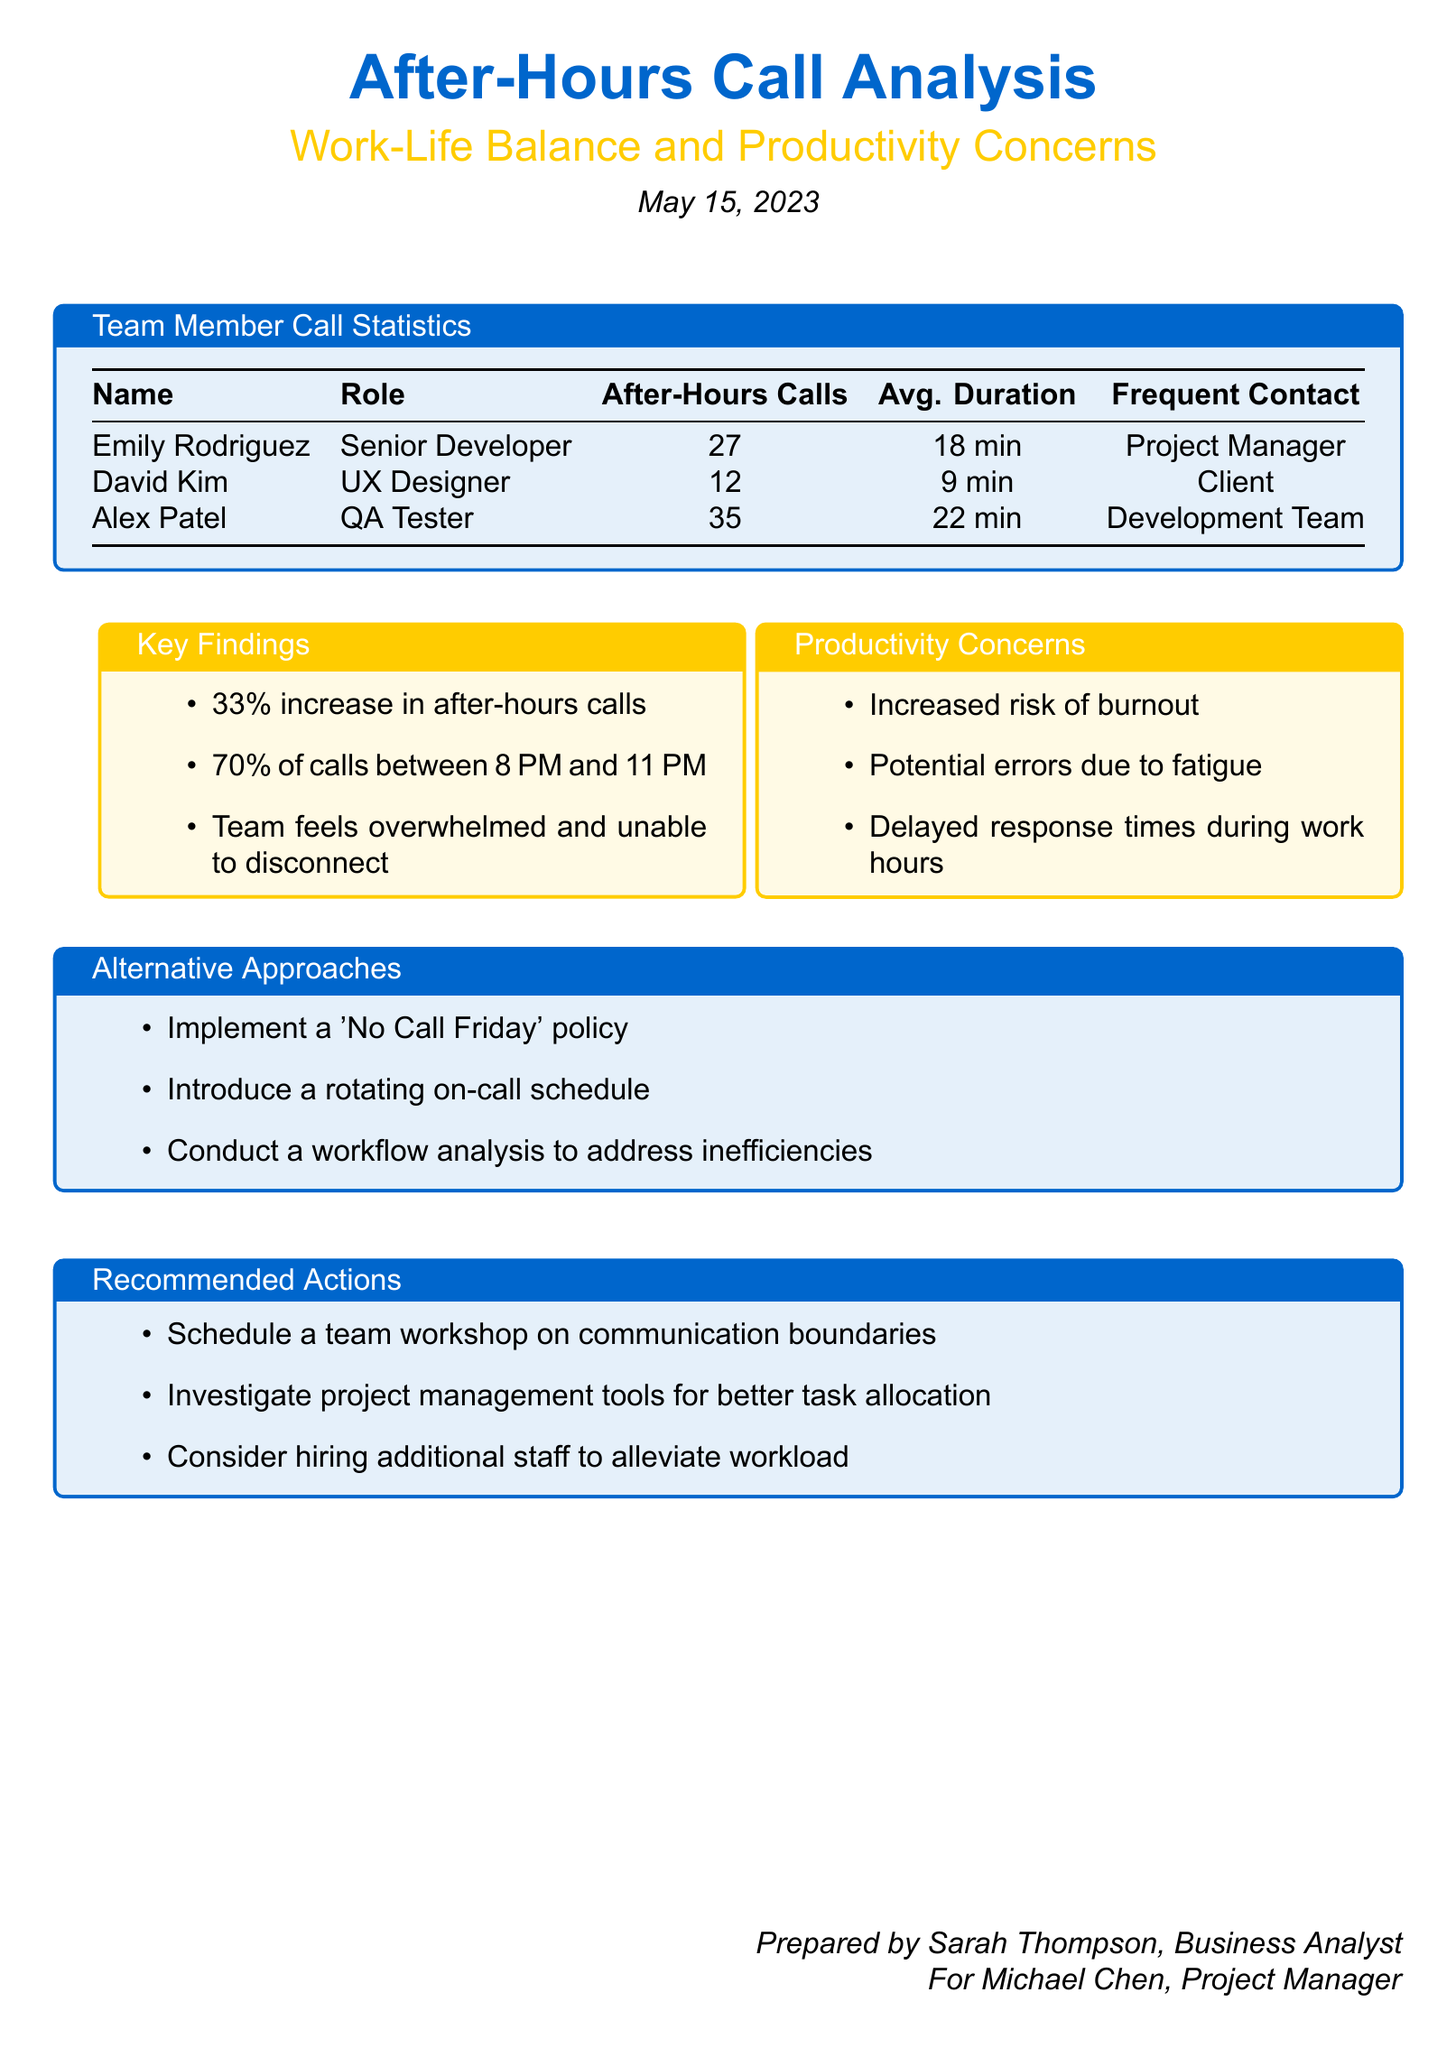What is the date of the report? The report is dated May 15, 2023.
Answer: May 15, 2023 Who made the most after-hours calls? Alex Patel made the most with 35 calls.
Answer: Alex Patel What percentage increase in after-hours calls is reported? The report states that there is a 33% increase.
Answer: 33% What is the average duration of calls made by David Kim? The average duration for David Kim's calls is 9 minutes.
Answer: 9 min What is one alternative approach suggested in the document? One suggestion is to implement a 'No Call Friday' policy.
Answer: 'No Call Friday' policy How many calls were made between 8 PM and 11 PM? The document specifies that 70% of calls occurred during this timeframe.
Answer: 70% What role does Emily Rodriguez hold? Emily Rodriguez is identified as a Senior Developer in the report.
Answer: Senior Developer What is one potential risk mentioned due to increased after-hours calls? The document mentions an increased risk of burnout.
Answer: burnout 